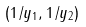<formula> <loc_0><loc_0><loc_500><loc_500>( 1 / y _ { 1 } , 1 / y _ { 2 } )</formula> 